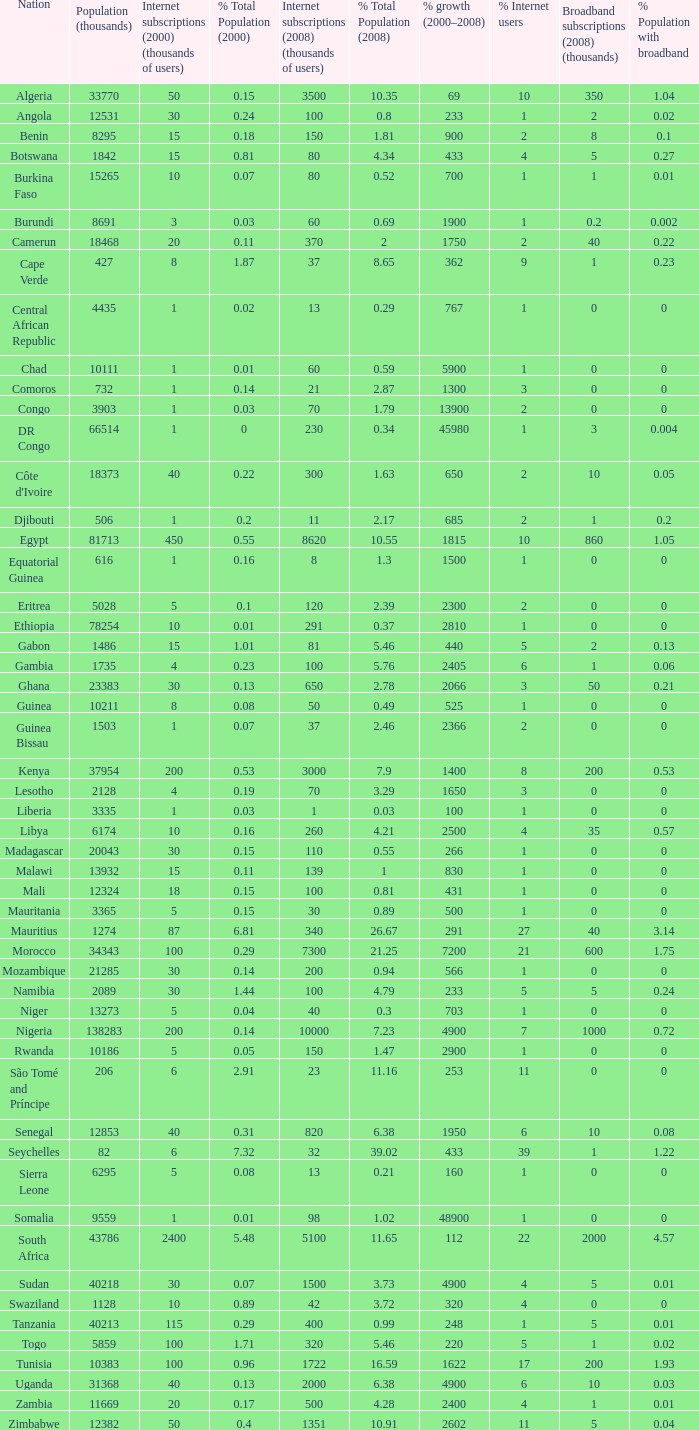What is the maximum percentage grown 2000-2008 in burundi 1900.0. 